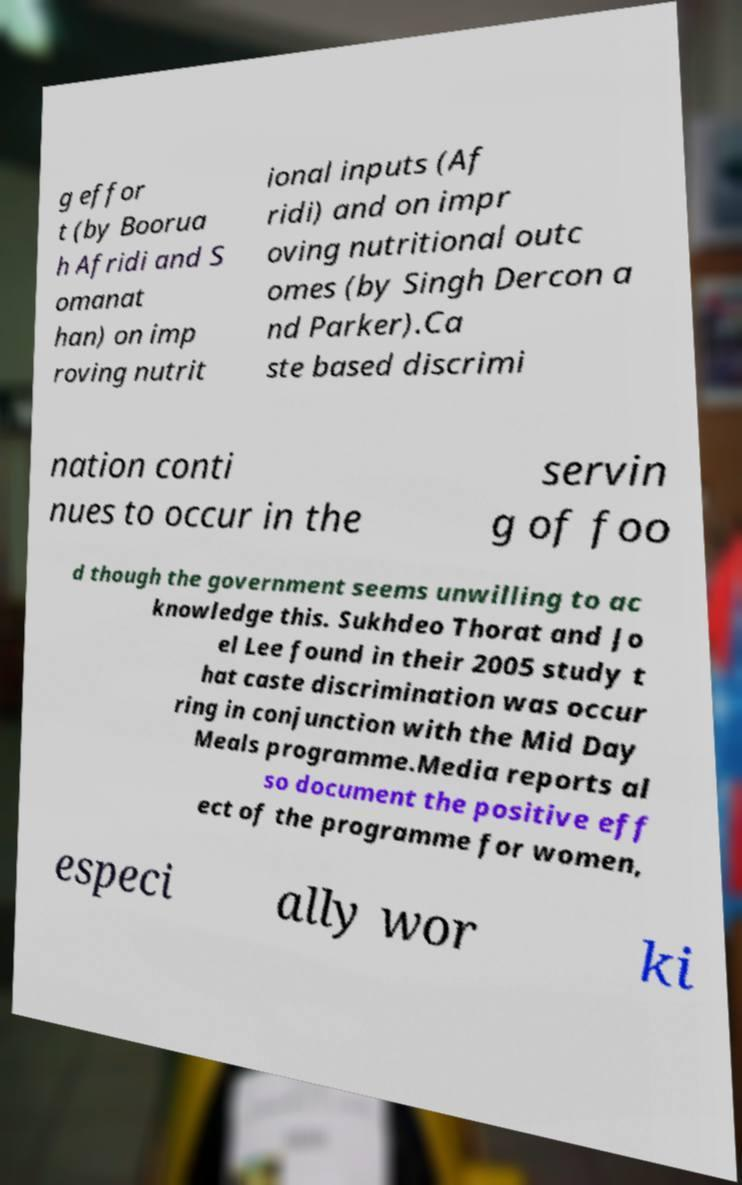Please identify and transcribe the text found in this image. g effor t (by Boorua h Afridi and S omanat han) on imp roving nutrit ional inputs (Af ridi) and on impr oving nutritional outc omes (by Singh Dercon a nd Parker).Ca ste based discrimi nation conti nues to occur in the servin g of foo d though the government seems unwilling to ac knowledge this. Sukhdeo Thorat and Jo el Lee found in their 2005 study t hat caste discrimination was occur ring in conjunction with the Mid Day Meals programme.Media reports al so document the positive eff ect of the programme for women, especi ally wor ki 